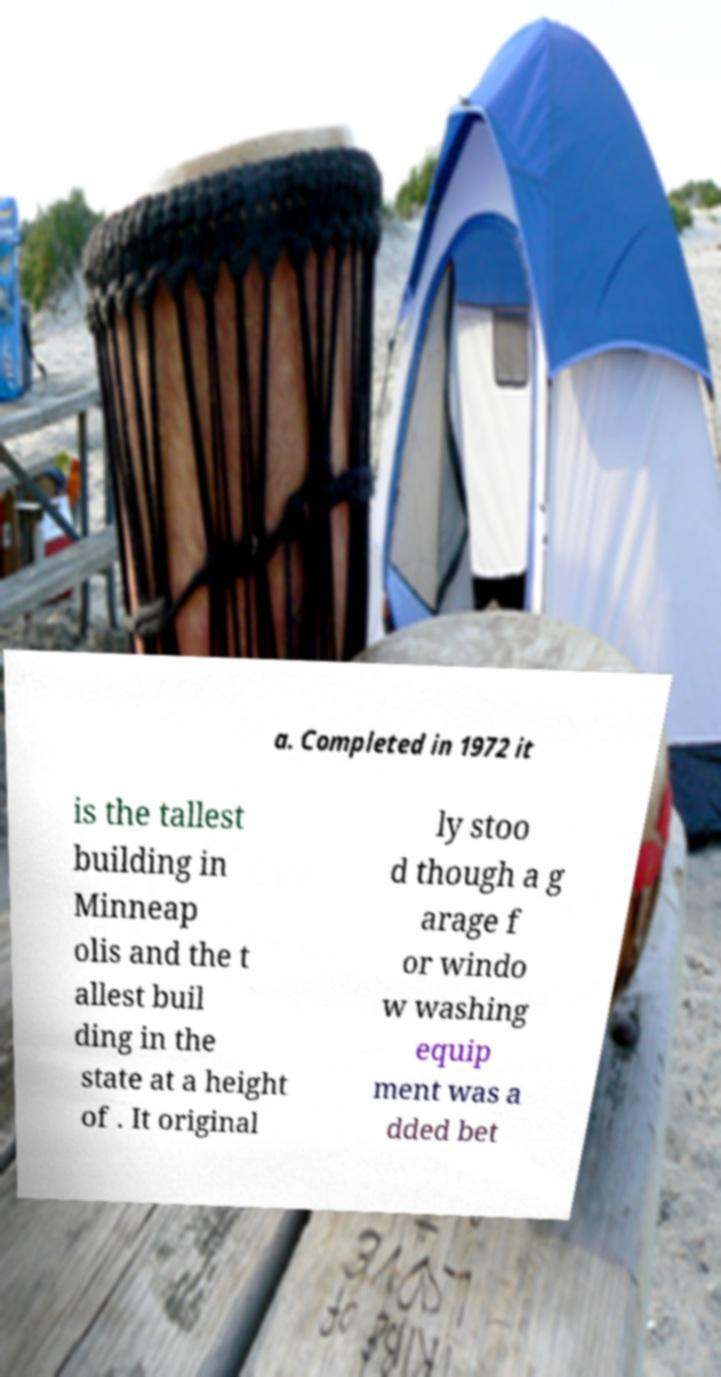Please read and relay the text visible in this image. What does it say? a. Completed in 1972 it is the tallest building in Minneap olis and the t allest buil ding in the state at a height of . It original ly stoo d though a g arage f or windo w washing equip ment was a dded bet 